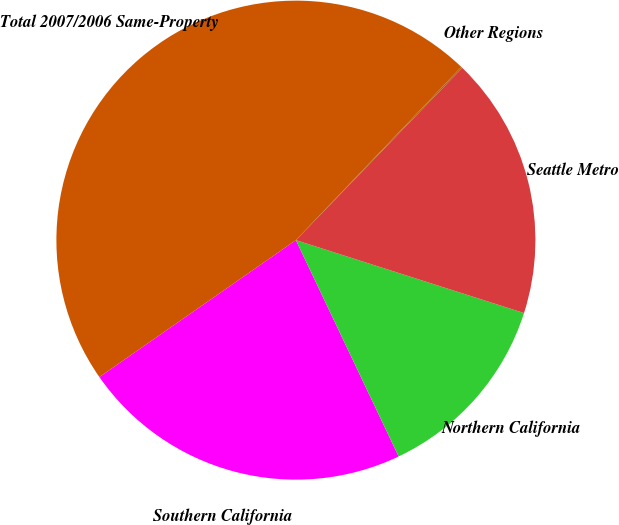Convert chart. <chart><loc_0><loc_0><loc_500><loc_500><pie_chart><fcel>Southern California<fcel>Northern California<fcel>Seattle Metro<fcel>Other Regions<fcel>Total 2007/2006 Same-Property<nl><fcel>22.37%<fcel>13.02%<fcel>17.7%<fcel>0.09%<fcel>46.82%<nl></chart> 